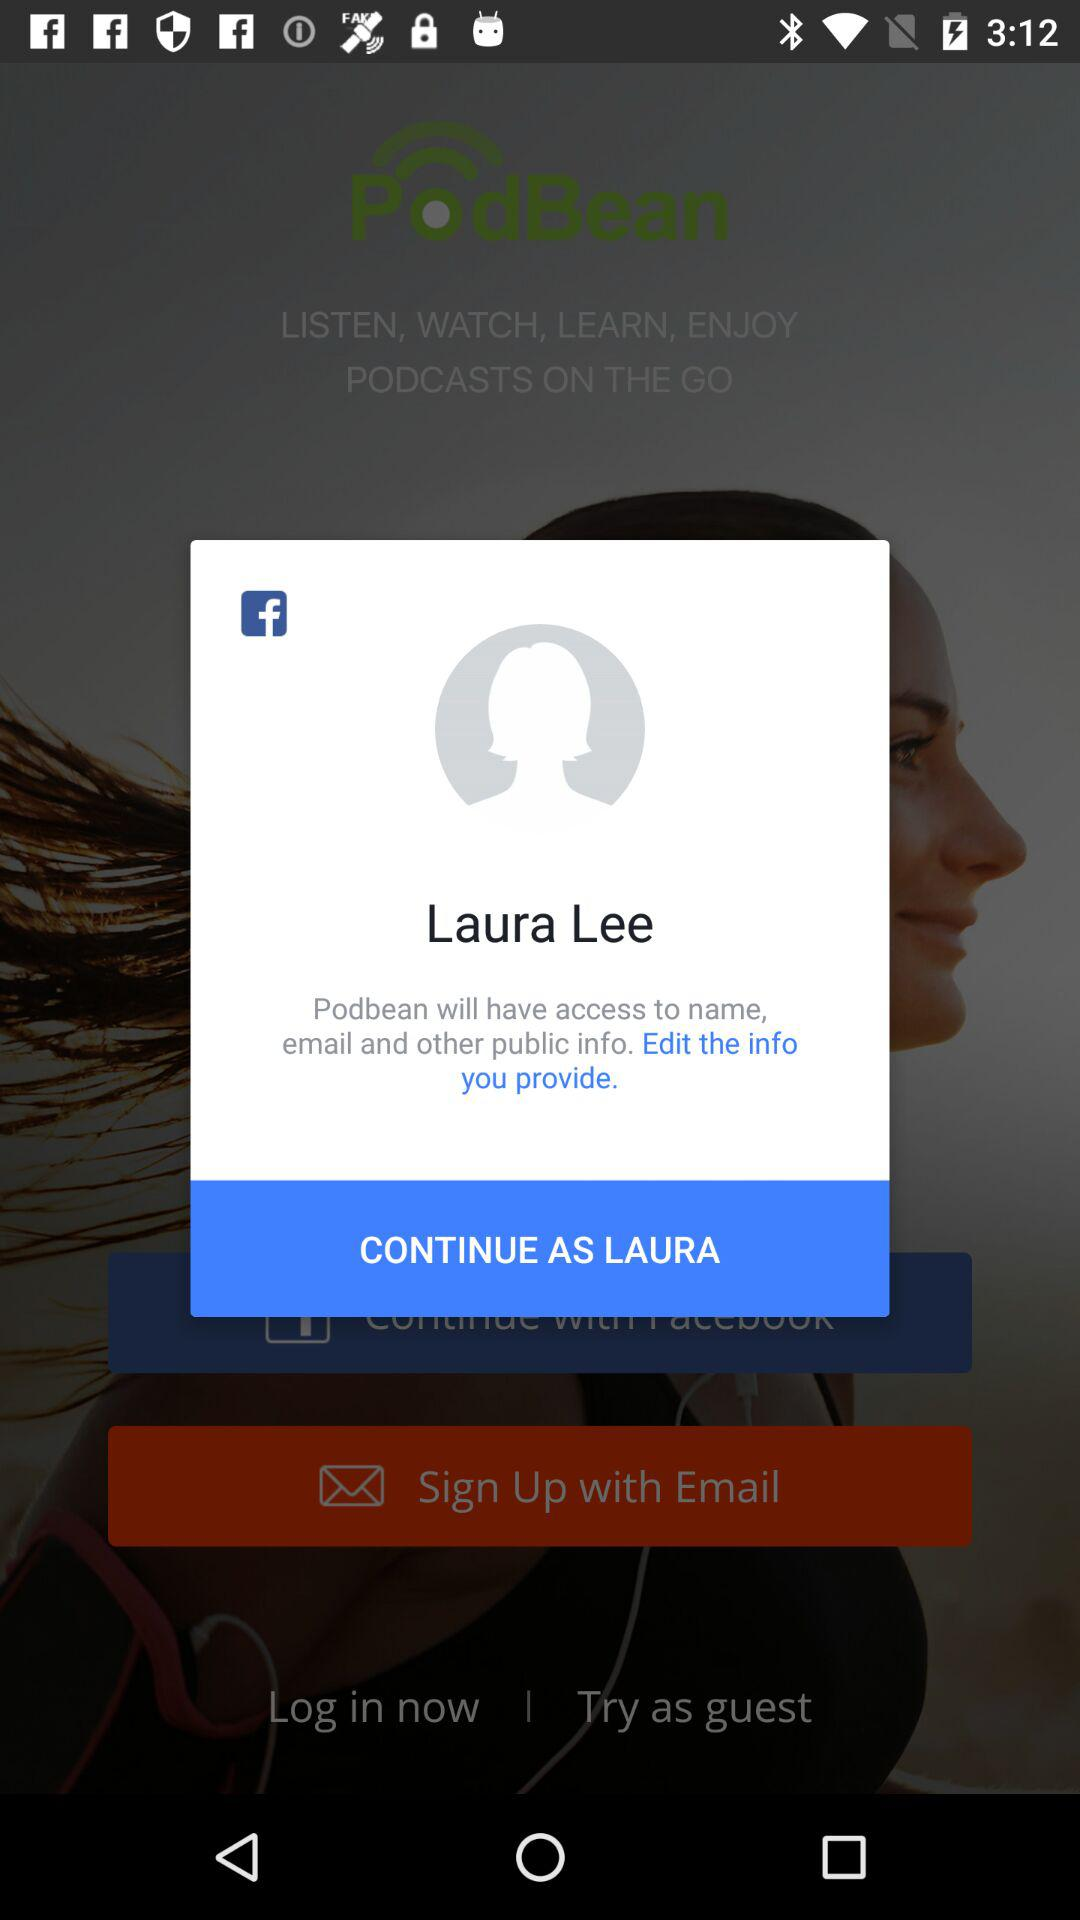What is the name of the user? The name of the user is Laura Lee. 